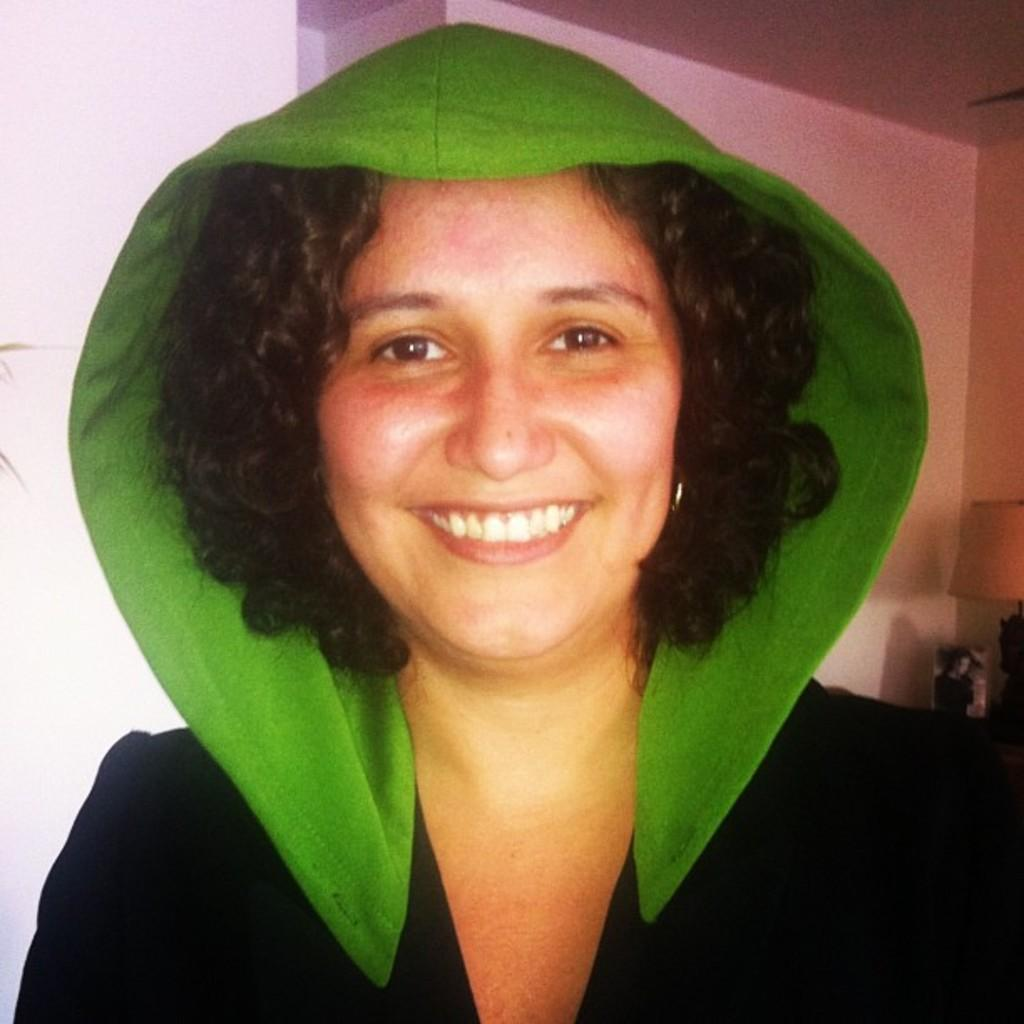What is the woman doing in the image? The woman is standing and smiling in the image. What object can be seen on the table in the image? There is a lamp on the table in the image. Can you describe the table in the image? The table is present in the image, and a lamp is placed on it. Reasoning: Let' Let's think step by step in order to produce the conversation. We start by identifying the main subject in the image, which is the woman. Then, we describe her actions and expression. Next, we move on to the objects in the image, focusing on the table and the lamp. Each question is designed to elicit a specific detail about the image that is known from the provided facts. Absurd Question/Answer: How many trees can be seen through the door in the image? There is no door or trees present in the image. What type of mouth expression does the woman have in the image? The woman is smiling in the image, so her mouth expression is a smile. How many trees can be seen through the door in the image? There is no door or trees present in the image. What type of mouth expression does the woman have in the image? The woman is smiling in the image, so her mouth expression is a smile. 